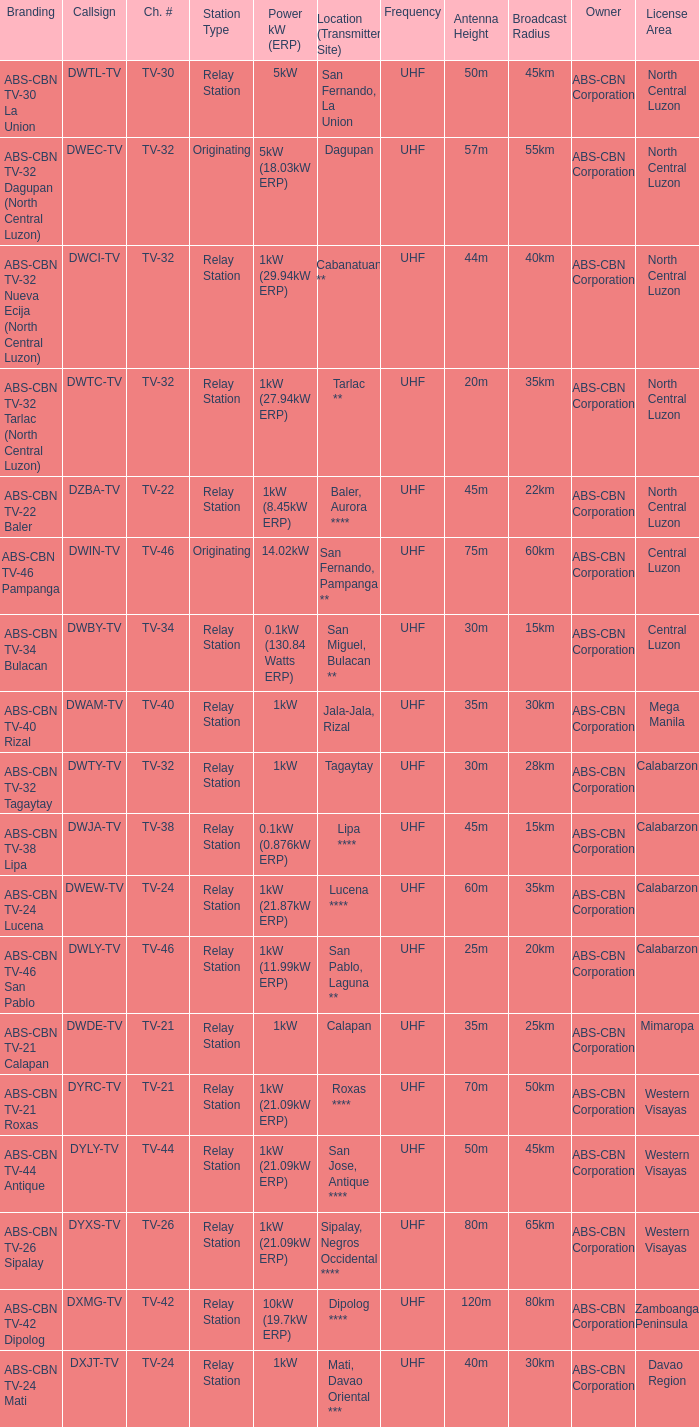The callsign DWEC-TV has what branding?  ABS-CBN TV-32 Dagupan (North Central Luzon). 